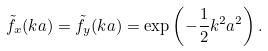Convert formula to latex. <formula><loc_0><loc_0><loc_500><loc_500>\tilde { f } _ { x } ( k a ) = \tilde { f } _ { y } ( k a ) = \exp \left ( - \frac { 1 } { 2 } k ^ { 2 } a ^ { 2 } \right ) .</formula> 